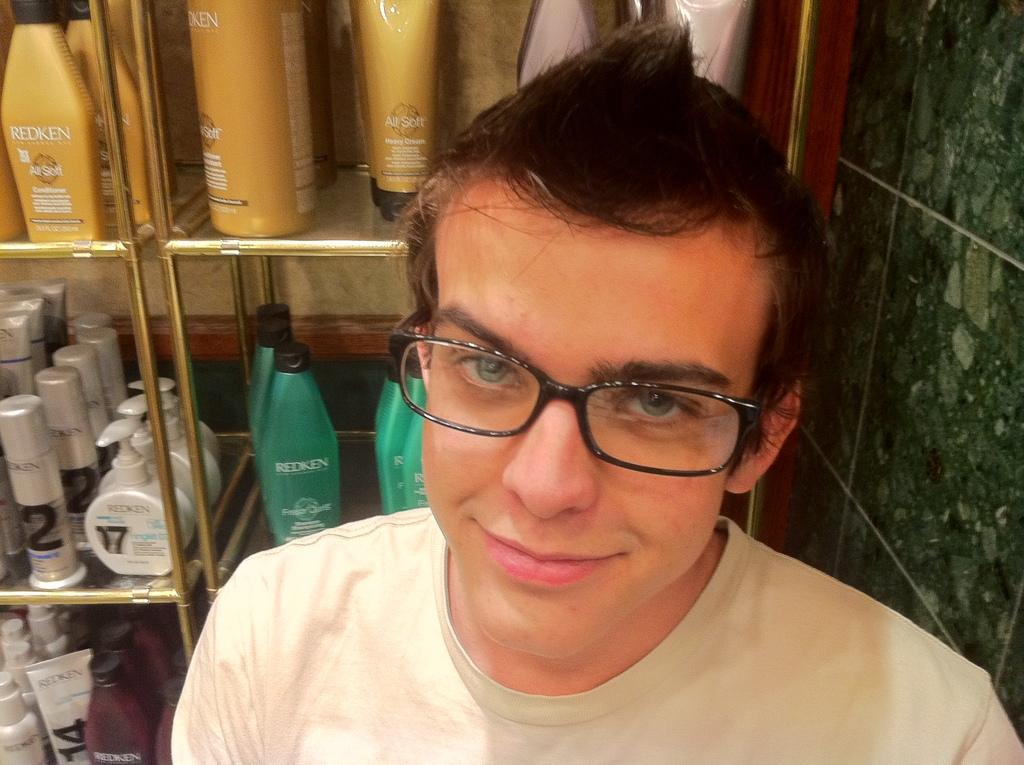<image>
Render a clear and concise summary of the photo. A person standing in front of a rack of Redken products. 